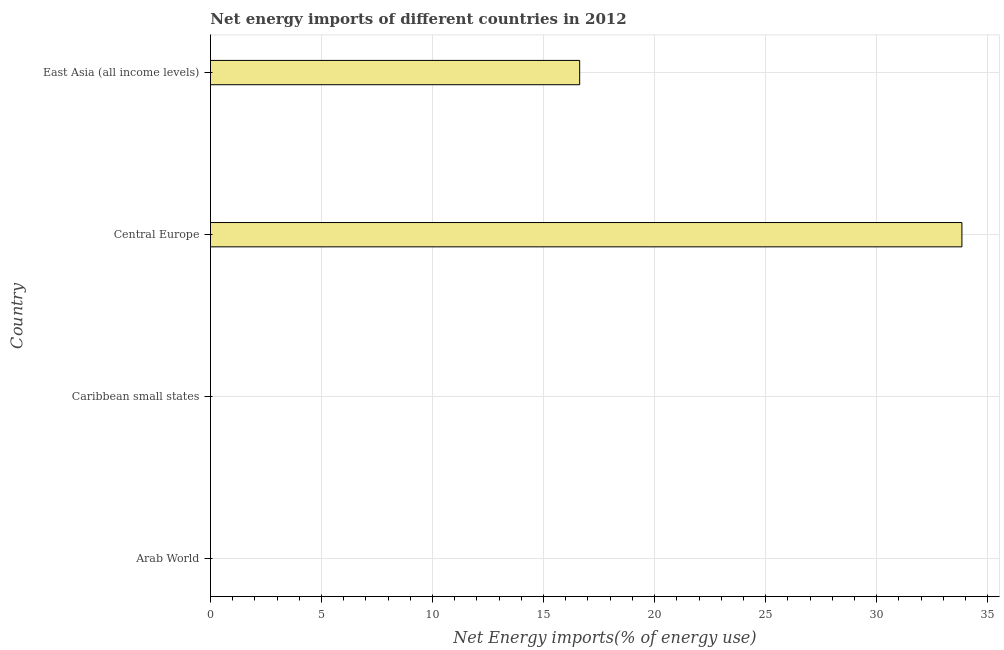Does the graph contain any zero values?
Provide a short and direct response. Yes. Does the graph contain grids?
Your answer should be very brief. Yes. What is the title of the graph?
Offer a very short reply. Net energy imports of different countries in 2012. What is the label or title of the X-axis?
Ensure brevity in your answer.  Net Energy imports(% of energy use). What is the label or title of the Y-axis?
Offer a terse response. Country. Across all countries, what is the maximum energy imports?
Provide a succinct answer. 33.84. Across all countries, what is the minimum energy imports?
Your response must be concise. 0. In which country was the energy imports maximum?
Give a very brief answer. Central Europe. What is the sum of the energy imports?
Offer a very short reply. 50.46. What is the average energy imports per country?
Make the answer very short. 12.62. What is the median energy imports?
Your answer should be compact. 8.31. In how many countries, is the energy imports greater than 15 %?
Your answer should be very brief. 2. What is the ratio of the energy imports in Central Europe to that in East Asia (all income levels)?
Keep it short and to the point. 2.04. Is the energy imports in Central Europe less than that in East Asia (all income levels)?
Ensure brevity in your answer.  No. What is the difference between the highest and the lowest energy imports?
Provide a succinct answer. 33.84. In how many countries, is the energy imports greater than the average energy imports taken over all countries?
Provide a short and direct response. 2. What is the difference between two consecutive major ticks on the X-axis?
Provide a short and direct response. 5. Are the values on the major ticks of X-axis written in scientific E-notation?
Ensure brevity in your answer.  No. What is the Net Energy imports(% of energy use) of Central Europe?
Your response must be concise. 33.84. What is the Net Energy imports(% of energy use) in East Asia (all income levels)?
Your response must be concise. 16.63. What is the difference between the Net Energy imports(% of energy use) in Central Europe and East Asia (all income levels)?
Give a very brief answer. 17.21. What is the ratio of the Net Energy imports(% of energy use) in Central Europe to that in East Asia (all income levels)?
Provide a succinct answer. 2.04. 